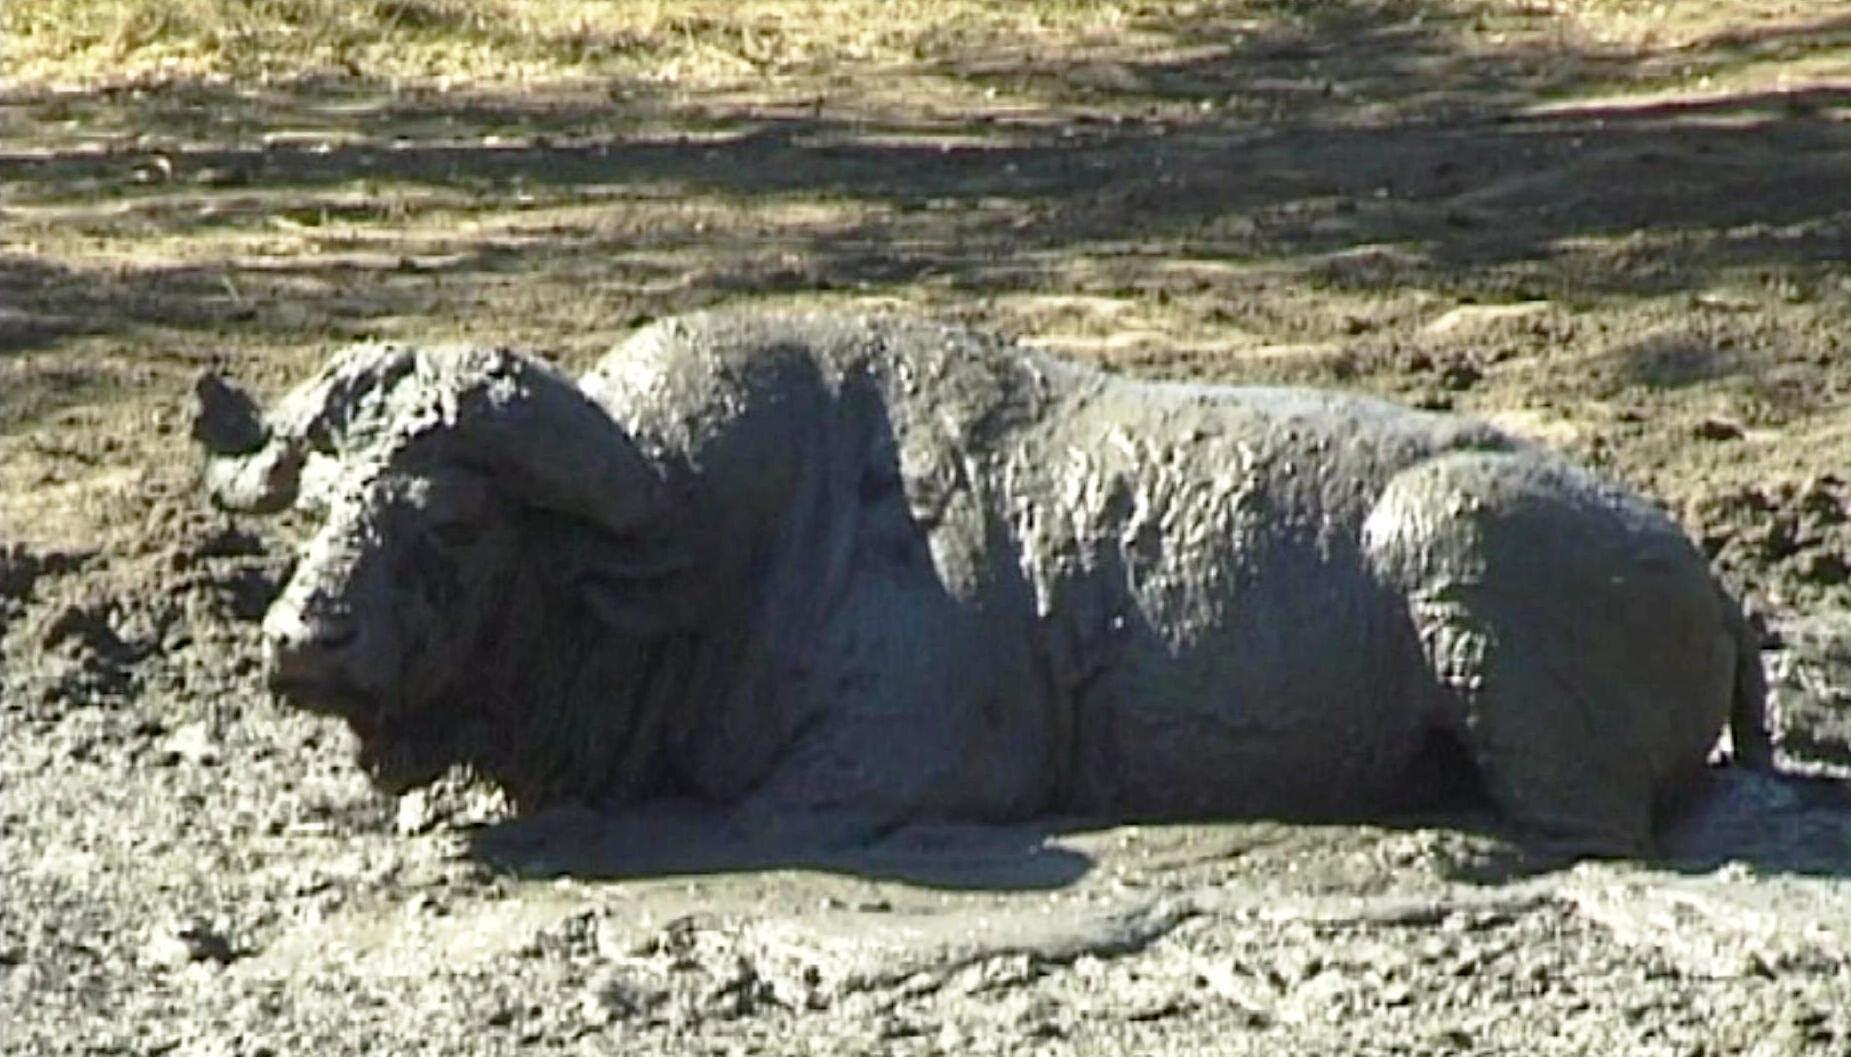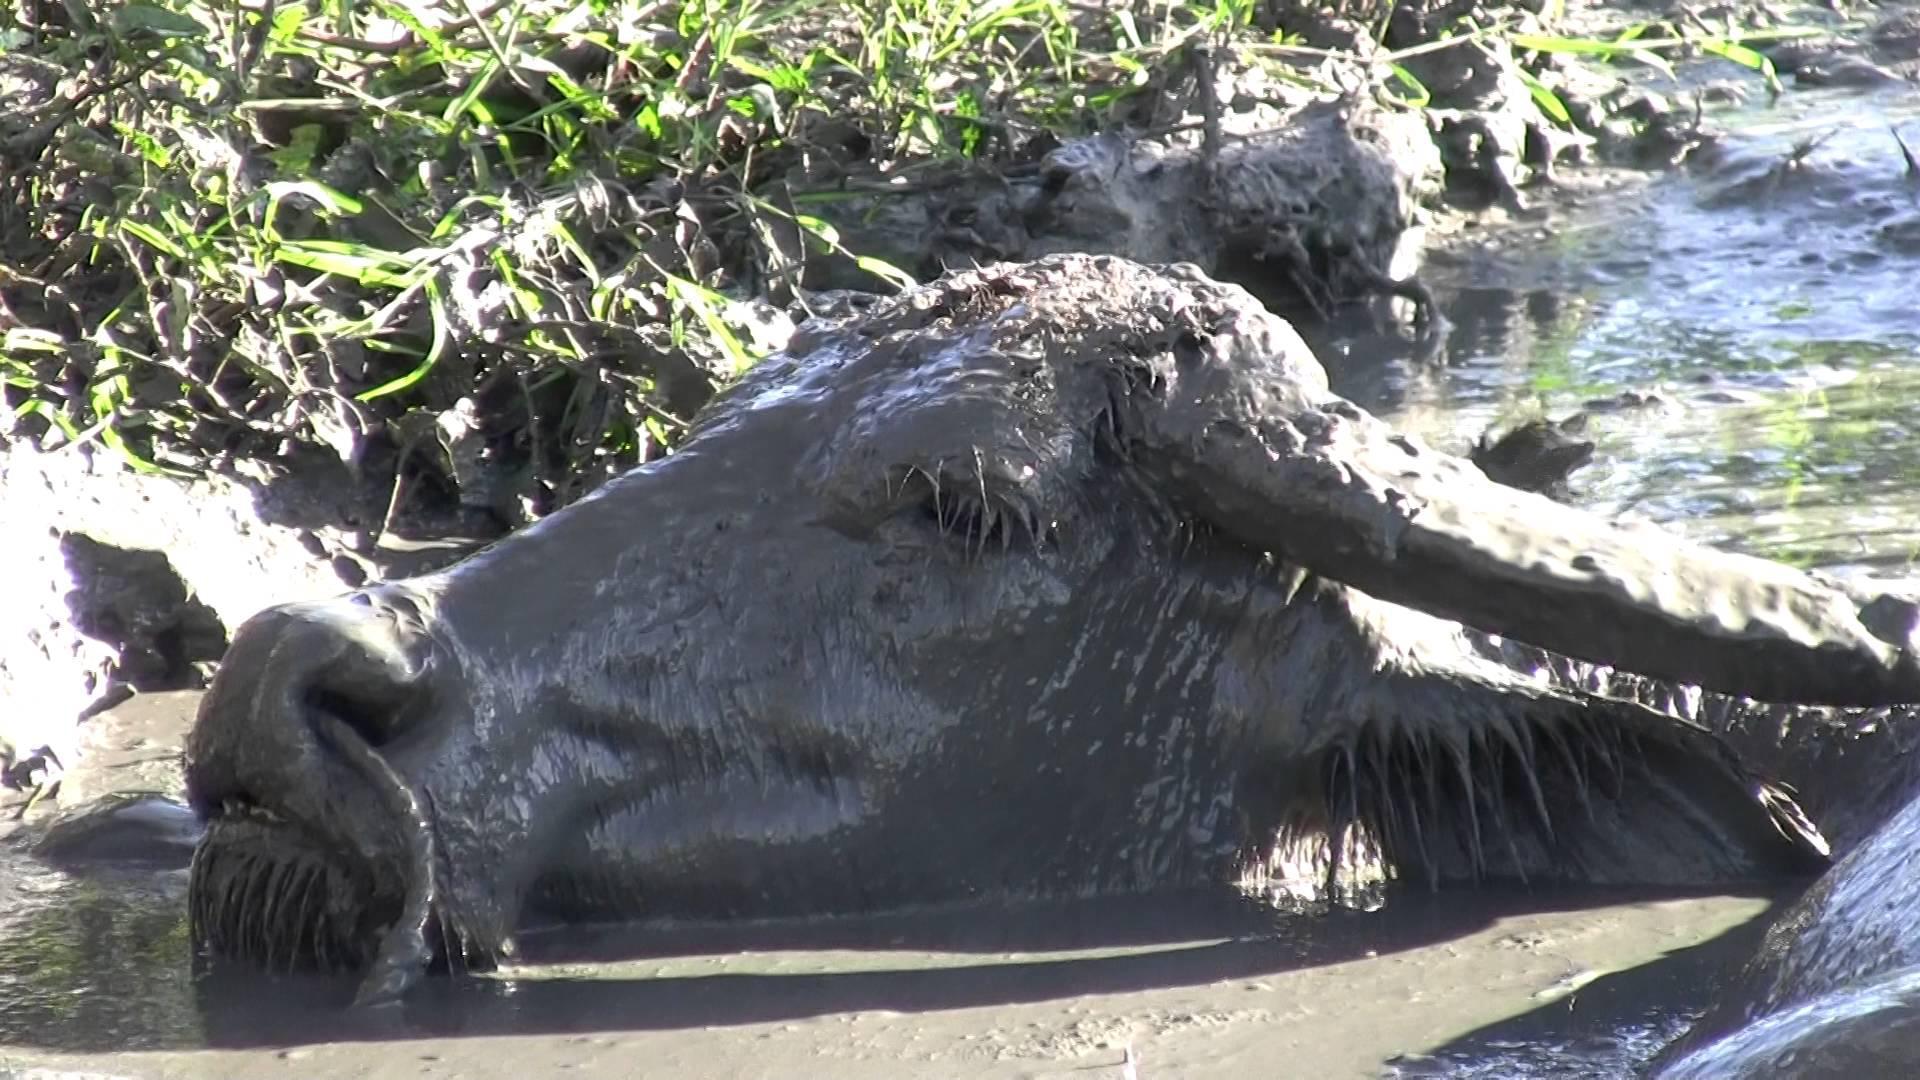The first image is the image on the left, the second image is the image on the right. Evaluate the accuracy of this statement regarding the images: "The cow in each image is standing past their legs in the mud.". Is it true? Answer yes or no. No. The first image is the image on the left, the second image is the image on the right. Considering the images on both sides, is "All water buffalo are in mud that reaches at least to their chest, and no image contains more than three water buffalo." valid? Answer yes or no. Yes. 